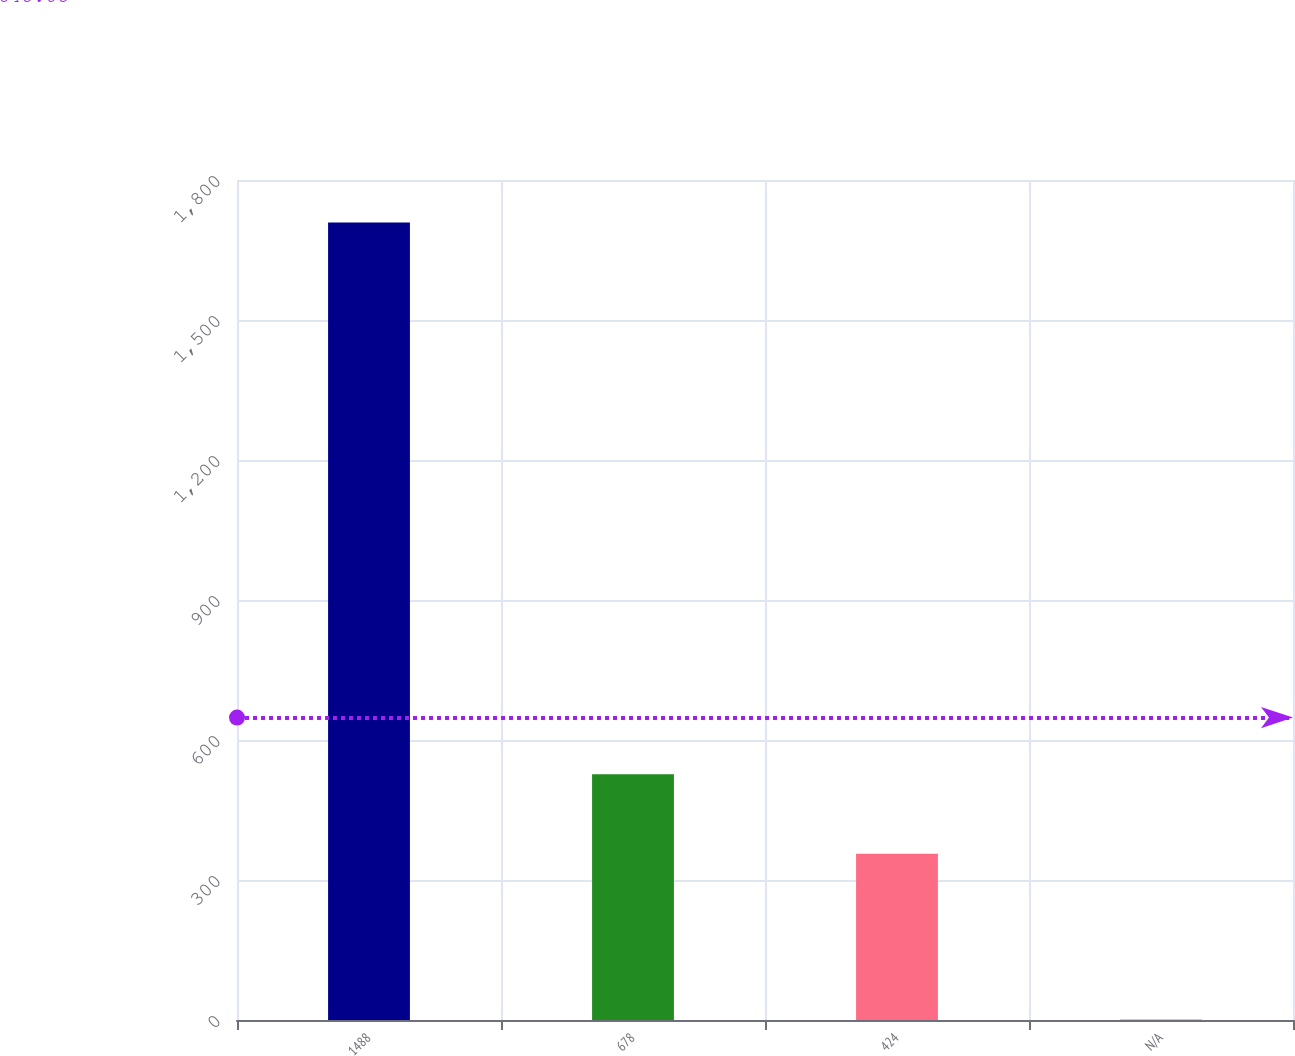<chart> <loc_0><loc_0><loc_500><loc_500><bar_chart><fcel>1488<fcel>678<fcel>424<fcel>N/A<nl><fcel>1709<fcel>526.86<fcel>356<fcel>0.45<nl></chart> 